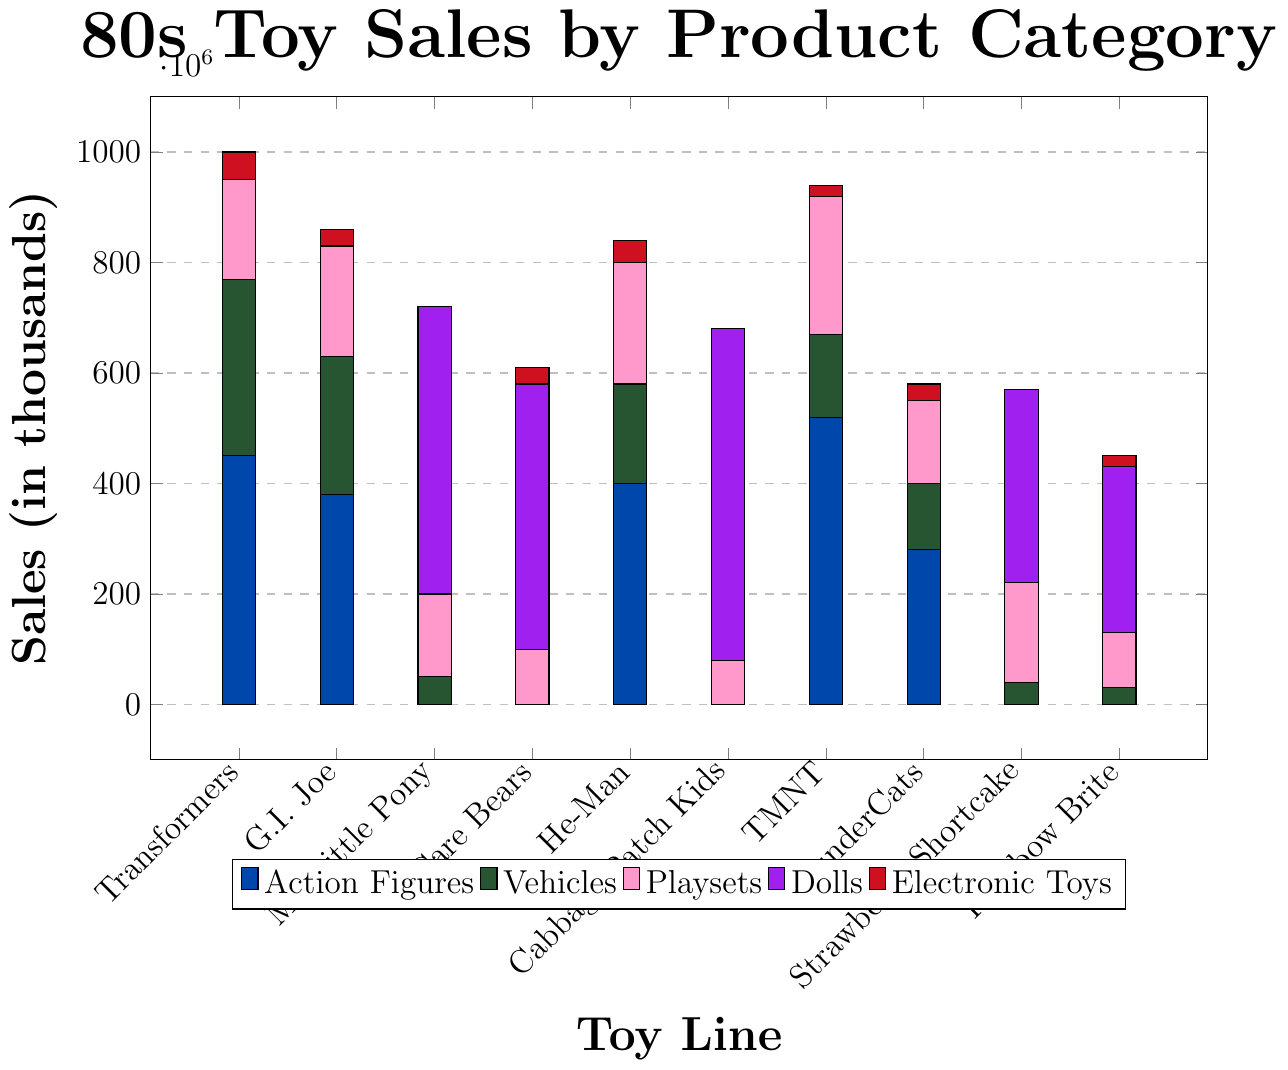Which toy line sold the most action figures? To determine which toy line sold the most action figures, we look at the highest bar in the action figures category, which is colored in blue. The highest bar corresponds to Teenage Mutant Ninja Turtles.
Answer: Teenage Mutant Ninja Turtles Which toy line had the highest total sales for playsets? We need to sum the sales of playsets from the pink bars and find the toy line with the largest pink bar. By visual inspection, the highest pink bar corresponds to Teenage Mutant Ninja Turtles.
Answer: Teenage Mutant Ninja Turtles How do the vehicle sales of He-Man compare to those of Transformers? We look at the green bars representing vehicle sales. He-Man’s green bar is shorter than Transformers’ green bar. The exact values are 180,000 for He-Man and 320,000 for Transformers.
Answer: He-Man sold fewer vehicles than Transformers Which toy line had the highest combined sales for dolls and electronic toys? We look at the doll (purple) and electronic toy (red) bars combined for each toy line. We then sum the heights of these bars for each toy line. Cabbage Patch Kids has the highest total sum of doll and electronic toy sales at 600,000 (dolls) + 0 (electronic toys) = 600,000.
Answer: Cabbage Patch Kids For which toy line do action figures constitute less than 50% of its total sales? We need to check each toy line where the blue bar (action figures) is less than half the total height of all bars for that toy line. For My Little Pony, Care Bears, Cabbage Patch Kids, Strawberry Shortcake, Rainbow Brite, and ThunderCats, action figures represent less than 50% of the total sales.
Answer: My Little Pony, Care Bears, Cabbage Patch Kids, Strawberry Shortcake, Rainbow Brite, ThunderCats What is the average sales figure for vehicles across all toy lines? To find the average, sum the vehicle sales across all toy lines and divide by the number of toy lines. Sum is 320,000 + 250,000 + 50,000 + 0 + 180,000 + 0 + 150,000 + 120,000 + 40,000 + 30,000 = 1,140,000. There are 10 toy lines: 1,140,000 / 10 = 114,000.
Answer: 114,000 Compare the total sales of G.I. Joe with the total sales of He-Man. Which one is higher? We sum the sales of all categories for each toy line. G.I. Joe total sales = 380,000 + 250,000 + 200,000 + 0 + 30,000 = 860,000. He-Man total sales = 400,000 + 180,000 + 220,000 + 0 + 40,000 = 840,000. G.I. Joe has higher total sales.
Answer: G.I. Joe Which toy line has the most diverse types of products in terms of sales figures? We look for the toy line with the most categories (action figures, vehicles, playsets, dolls, electronic toys) having non-zero sales. Transformers, G.I. Joe, He-Man, ThunderCats, and Rainbow Brite each sold in four categories, but Transformers’ sales are spread more evenly.
Answer: Transformers How do the combined sales of action figures for Transformers and G.I. Joe compare to the combined sales of dolls for My Little Pony and Care Bears? First, sum the action figure sales for Transformers and G.I. Joe: 450,000 + 380,000 = 830,000. Then, sum the doll sales for My Little Pony and Care Bears: 520,000 + 480,000 = 1,000,000. The combined sales of dolls for My Little Pony and Care Bears are higher.
Answer: Doll sales for My Little Pony and Care Bears are higher Which toy line sold more electronic toys, Rainbow Brite or Strawberry Shortcake? We compare the heights of the red bars for these two toy lines. Rainbow Brite's red bar is slightly taller than Strawberry Shortcake's. Rainbow Brite sold 20,000 electronic toys, while Strawberry Shortcake sold 0.
Answer: Rainbow Brite 